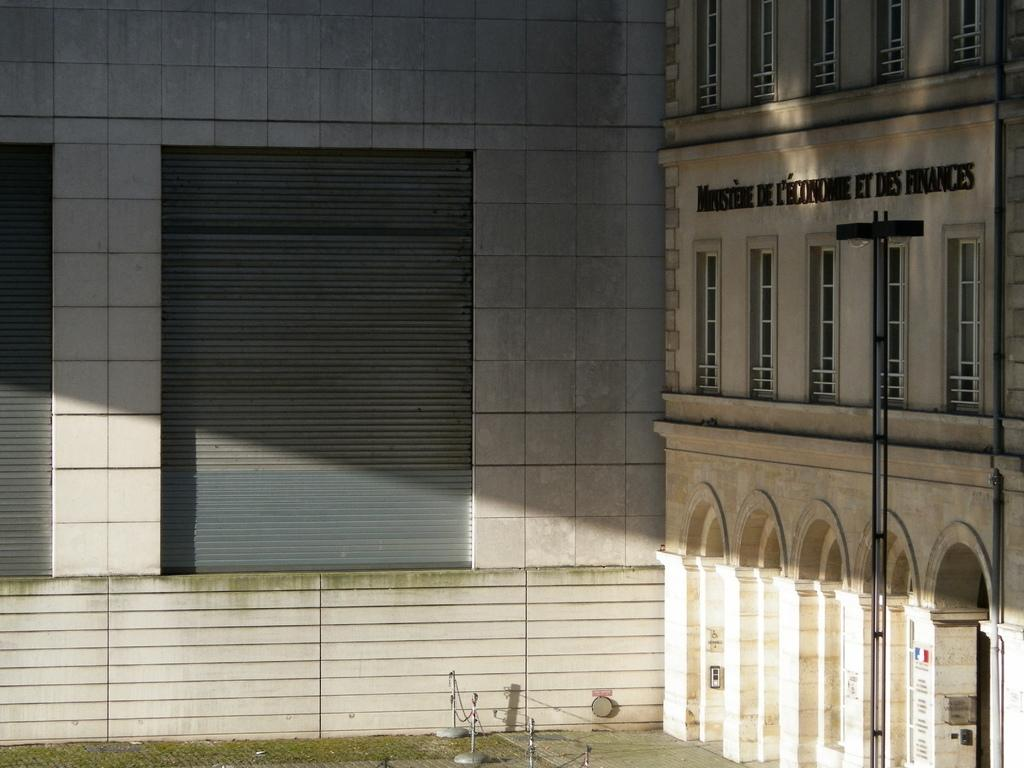What type of structure is visible in the image? There is a building in the image. What can be seen on the building? Text is written on the building. What architectural feature is present in the image? There is a wall with shutters in the image. What objects are attached to the wall? There are rods with chains in the image. What type of vegetation is present in the image? Grass is present in the image. How many bats are hanging from the rods with chains in the image? There are no bats present in the image; only rods with chains are visible. 